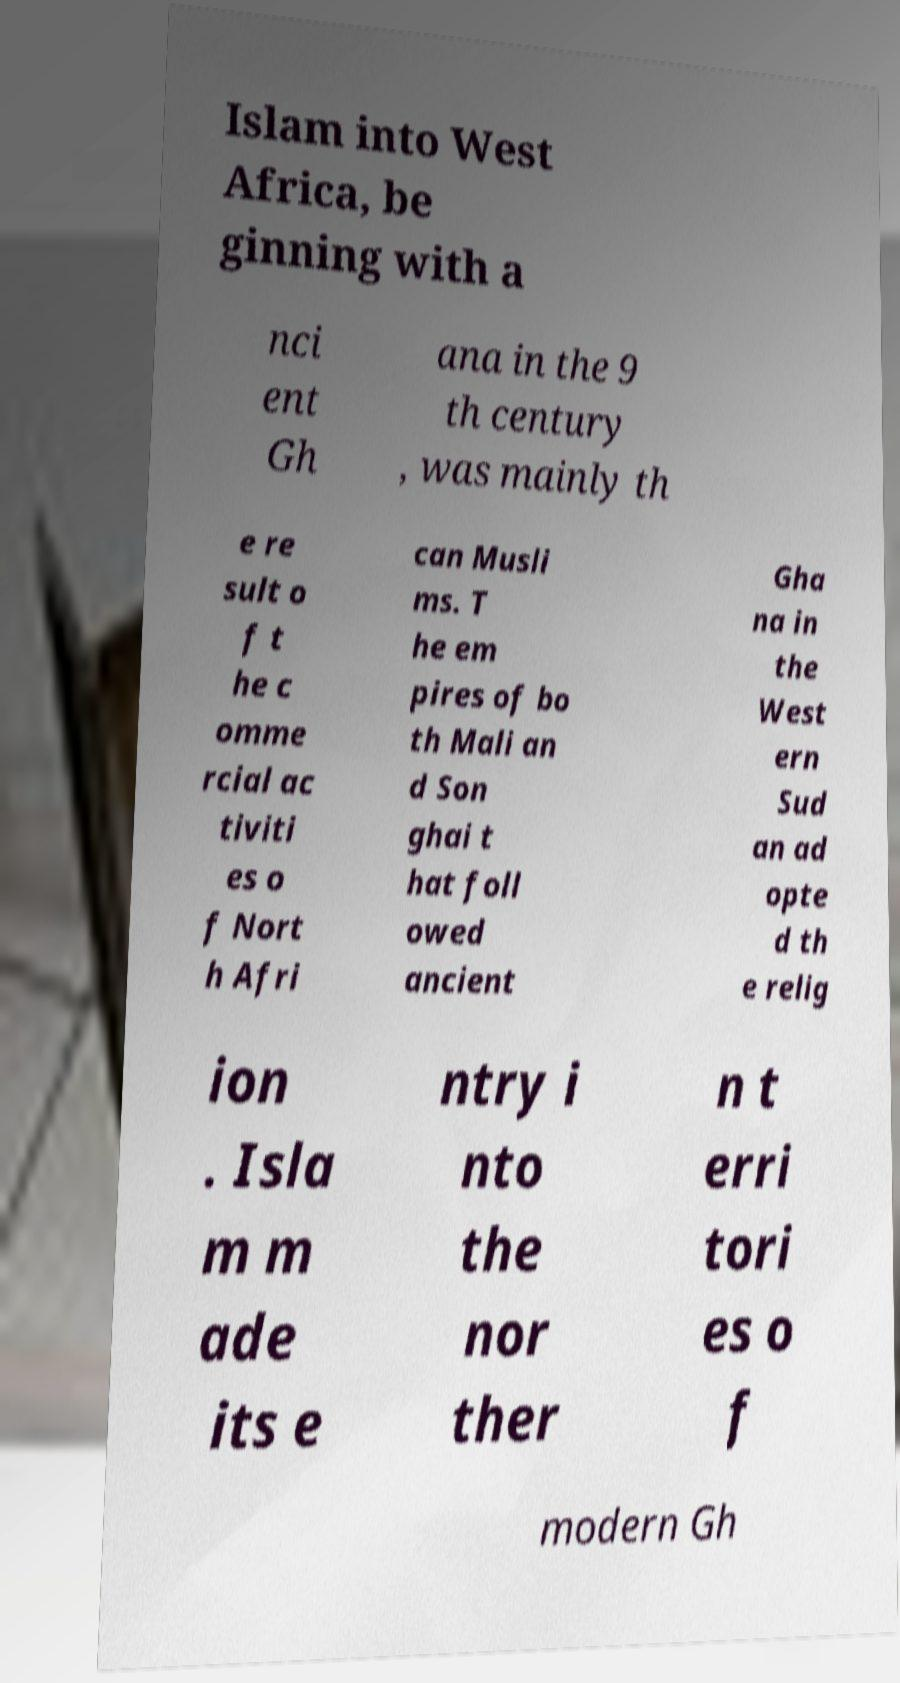What messages or text are displayed in this image? I need them in a readable, typed format. Islam into West Africa, be ginning with a nci ent Gh ana in the 9 th century , was mainly th e re sult o f t he c omme rcial ac tiviti es o f Nort h Afri can Musli ms. T he em pires of bo th Mali an d Son ghai t hat foll owed ancient Gha na in the West ern Sud an ad opte d th e relig ion . Isla m m ade its e ntry i nto the nor ther n t erri tori es o f modern Gh 